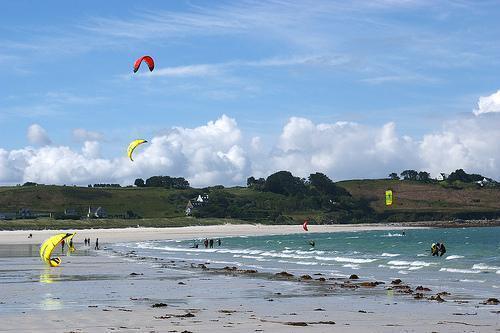How many red objects are in the sky?
Give a very brief answer. 1. 